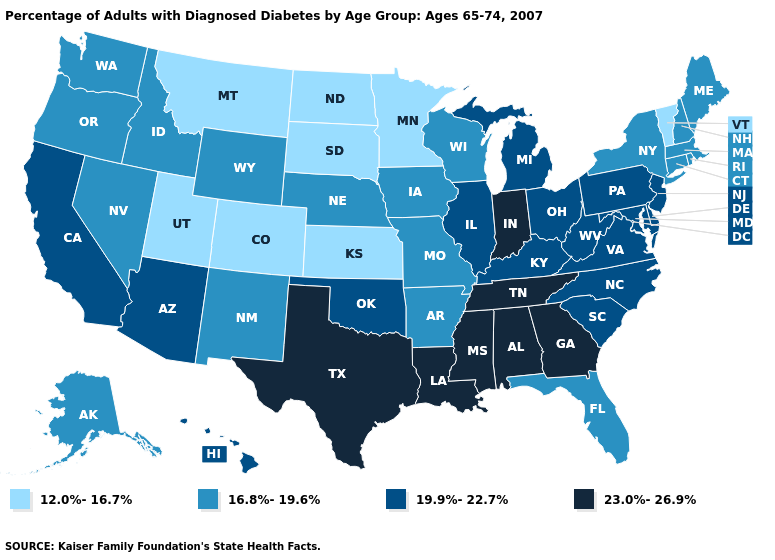What is the lowest value in states that border Maine?
Concise answer only. 16.8%-19.6%. Name the states that have a value in the range 16.8%-19.6%?
Be succinct. Alaska, Arkansas, Connecticut, Florida, Idaho, Iowa, Maine, Massachusetts, Missouri, Nebraska, Nevada, New Hampshire, New Mexico, New York, Oregon, Rhode Island, Washington, Wisconsin, Wyoming. Name the states that have a value in the range 12.0%-16.7%?
Answer briefly. Colorado, Kansas, Minnesota, Montana, North Dakota, South Dakota, Utah, Vermont. Name the states that have a value in the range 12.0%-16.7%?
Keep it brief. Colorado, Kansas, Minnesota, Montana, North Dakota, South Dakota, Utah, Vermont. What is the lowest value in states that border Rhode Island?
Short answer required. 16.8%-19.6%. Name the states that have a value in the range 19.9%-22.7%?
Quick response, please. Arizona, California, Delaware, Hawaii, Illinois, Kentucky, Maryland, Michigan, New Jersey, North Carolina, Ohio, Oklahoma, Pennsylvania, South Carolina, Virginia, West Virginia. Is the legend a continuous bar?
Keep it brief. No. What is the value of Oklahoma?
Write a very short answer. 19.9%-22.7%. What is the value of New Mexico?
Quick response, please. 16.8%-19.6%. Name the states that have a value in the range 12.0%-16.7%?
Keep it brief. Colorado, Kansas, Minnesota, Montana, North Dakota, South Dakota, Utah, Vermont. Name the states that have a value in the range 16.8%-19.6%?
Keep it brief. Alaska, Arkansas, Connecticut, Florida, Idaho, Iowa, Maine, Massachusetts, Missouri, Nebraska, Nevada, New Hampshire, New Mexico, New York, Oregon, Rhode Island, Washington, Wisconsin, Wyoming. Among the states that border North Carolina , does Tennessee have the highest value?
Short answer required. Yes. Does Minnesota have the highest value in the USA?
Write a very short answer. No. Does Montana have the same value as Nevada?
Quick response, please. No. What is the value of Texas?
Short answer required. 23.0%-26.9%. 